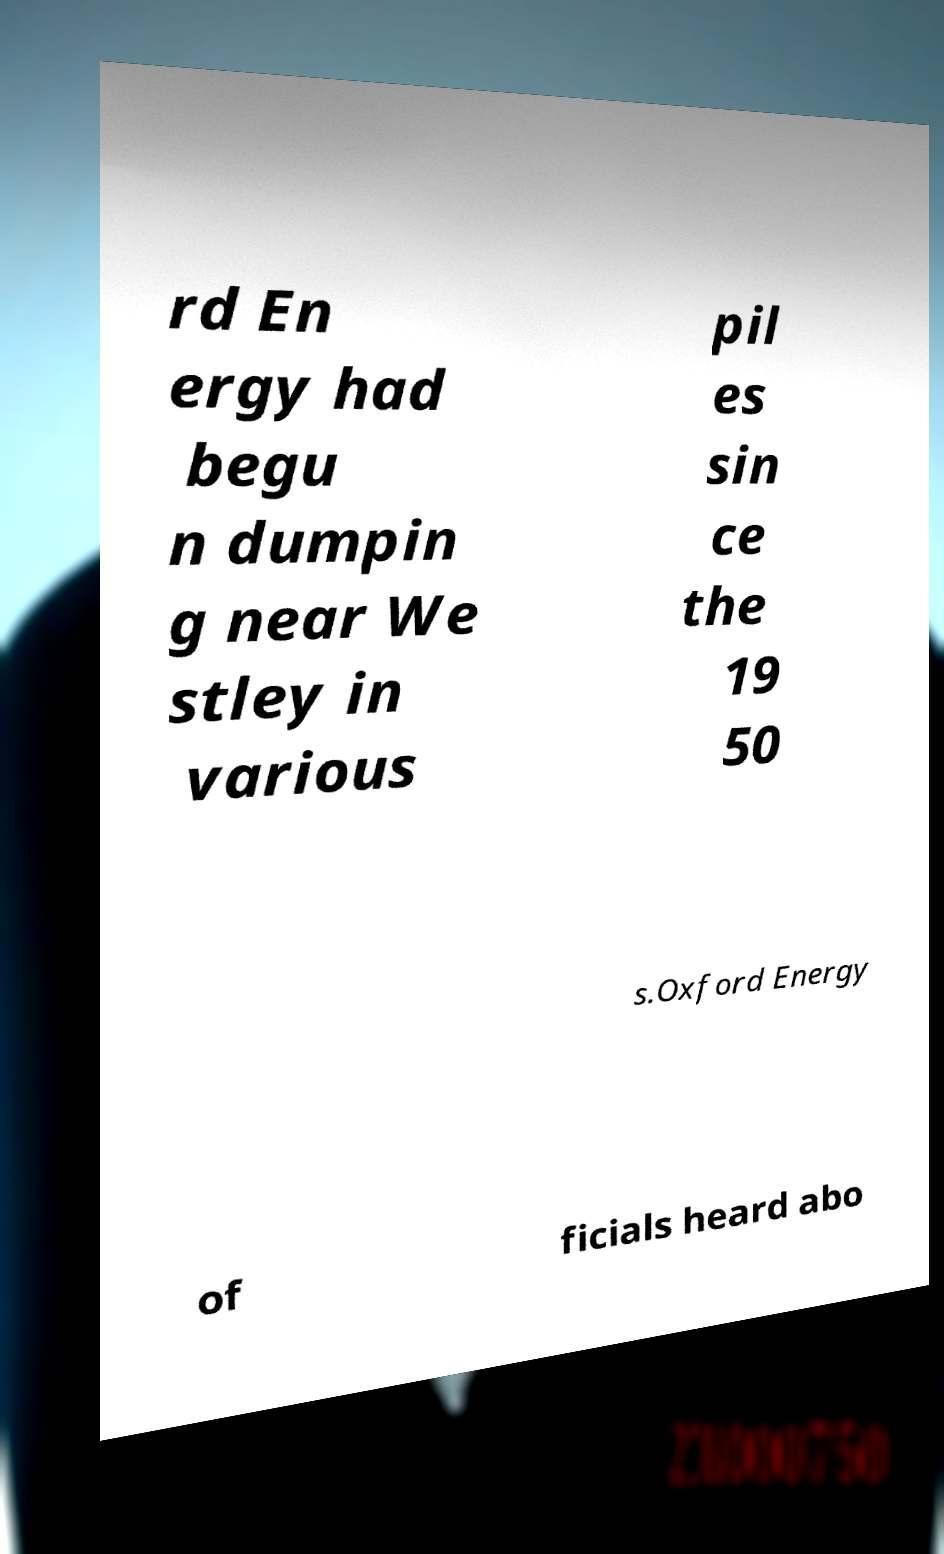For documentation purposes, I need the text within this image transcribed. Could you provide that? rd En ergy had begu n dumpin g near We stley in various pil es sin ce the 19 50 s.Oxford Energy of ficials heard abo 